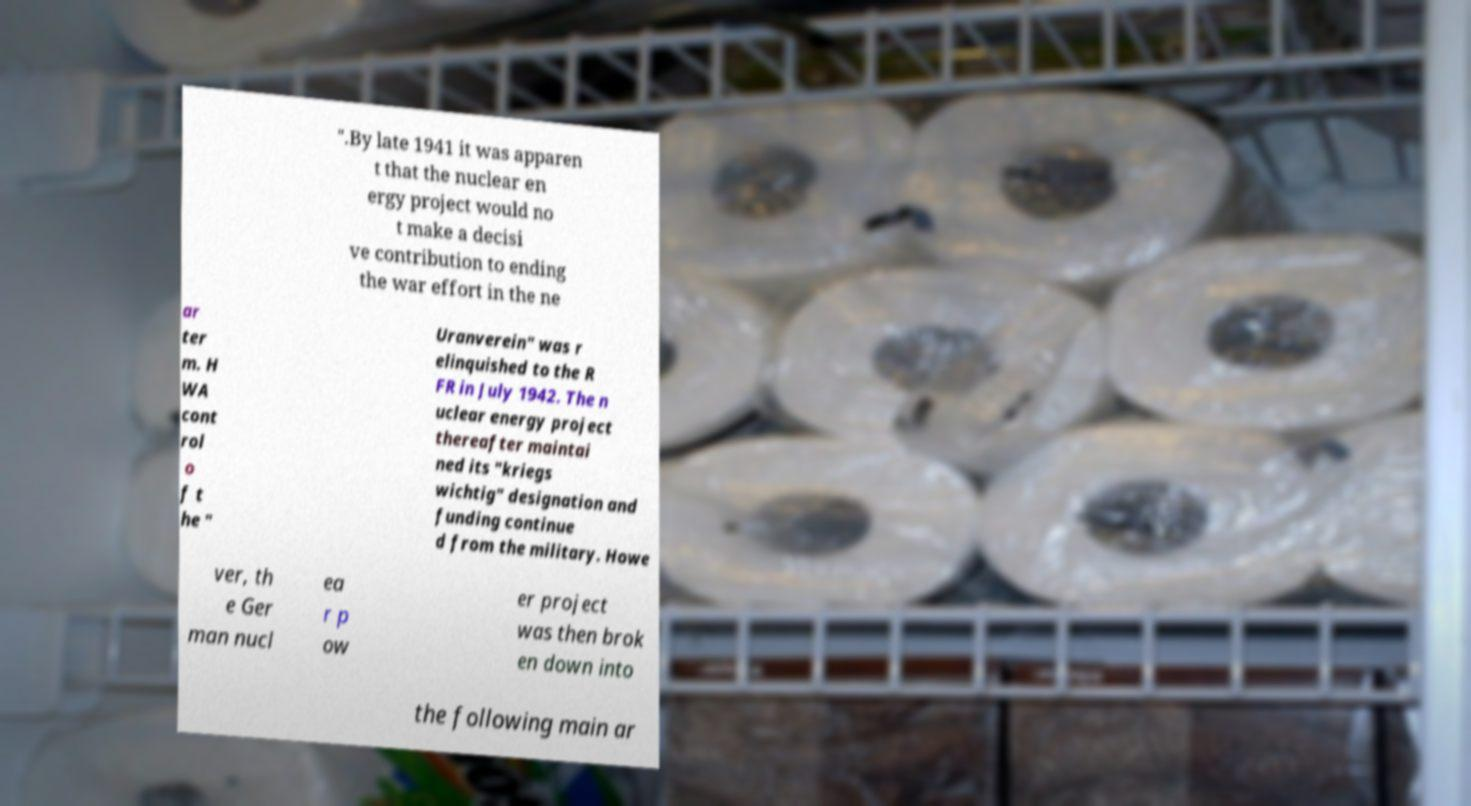Can you read and provide the text displayed in the image?This photo seems to have some interesting text. Can you extract and type it out for me? ".By late 1941 it was apparen t that the nuclear en ergy project would no t make a decisi ve contribution to ending the war effort in the ne ar ter m. H WA cont rol o f t he " Uranverein" was r elinquished to the R FR in July 1942. The n uclear energy project thereafter maintai ned its "kriegs wichtig" designation and funding continue d from the military. Howe ver, th e Ger man nucl ea r p ow er project was then brok en down into the following main ar 